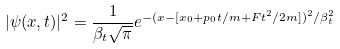<formula> <loc_0><loc_0><loc_500><loc_500>| \psi ( x , t ) | ^ { 2 } = \frac { 1 } { \beta _ { t } \sqrt { \pi } } e ^ { - ( x - [ x _ { 0 } + p _ { 0 } t / m + F t ^ { 2 } / 2 m ] ) ^ { 2 } / \beta _ { t } ^ { 2 } }</formula> 